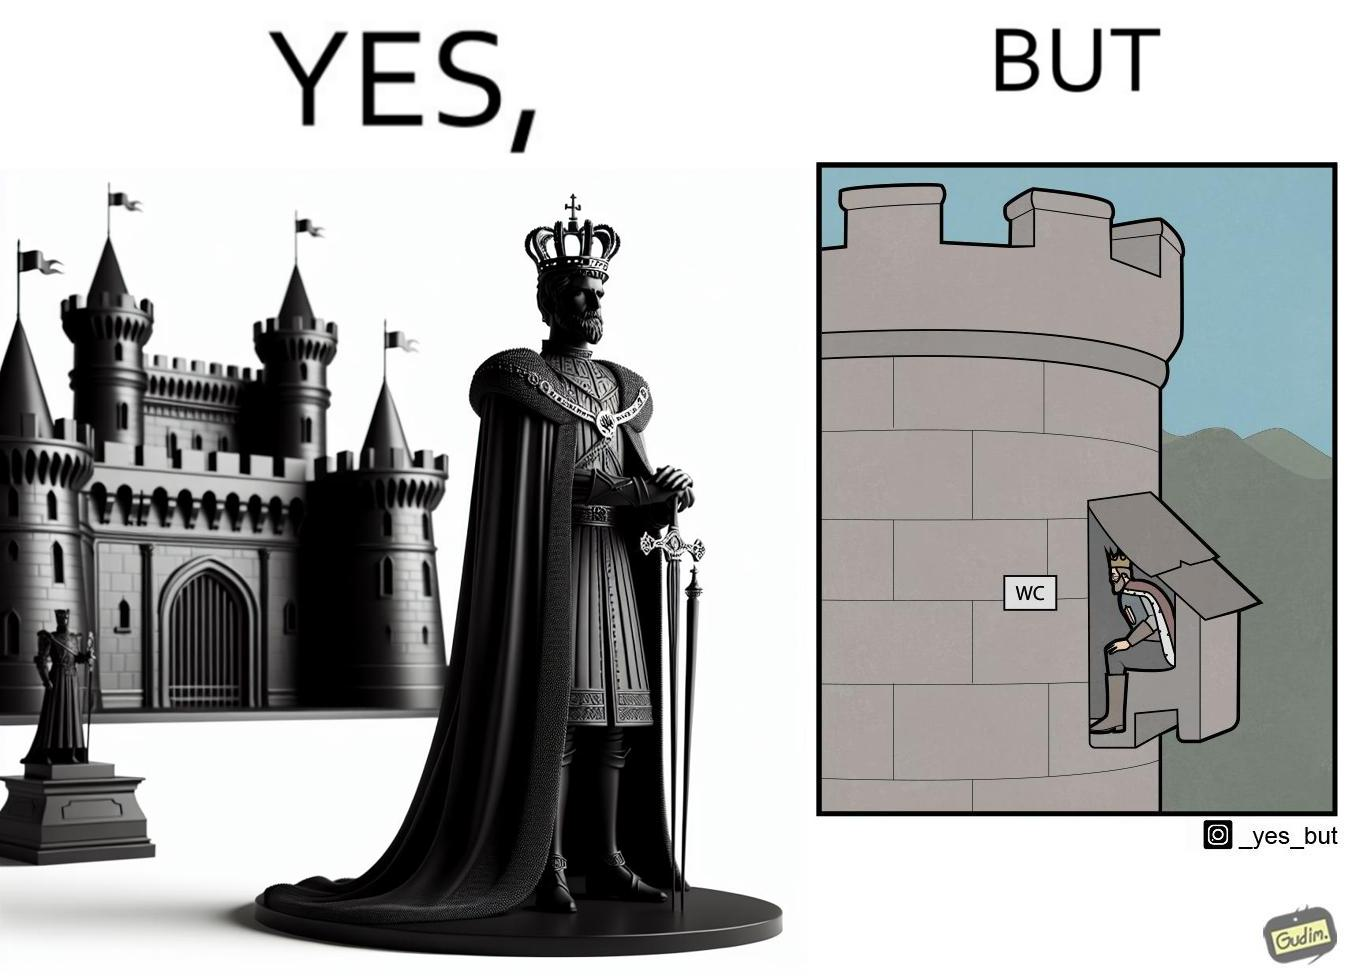Provide a description of this image. The images are funny since it shows how even a mighty king must do simple things like using a toilet just like everyone else does 